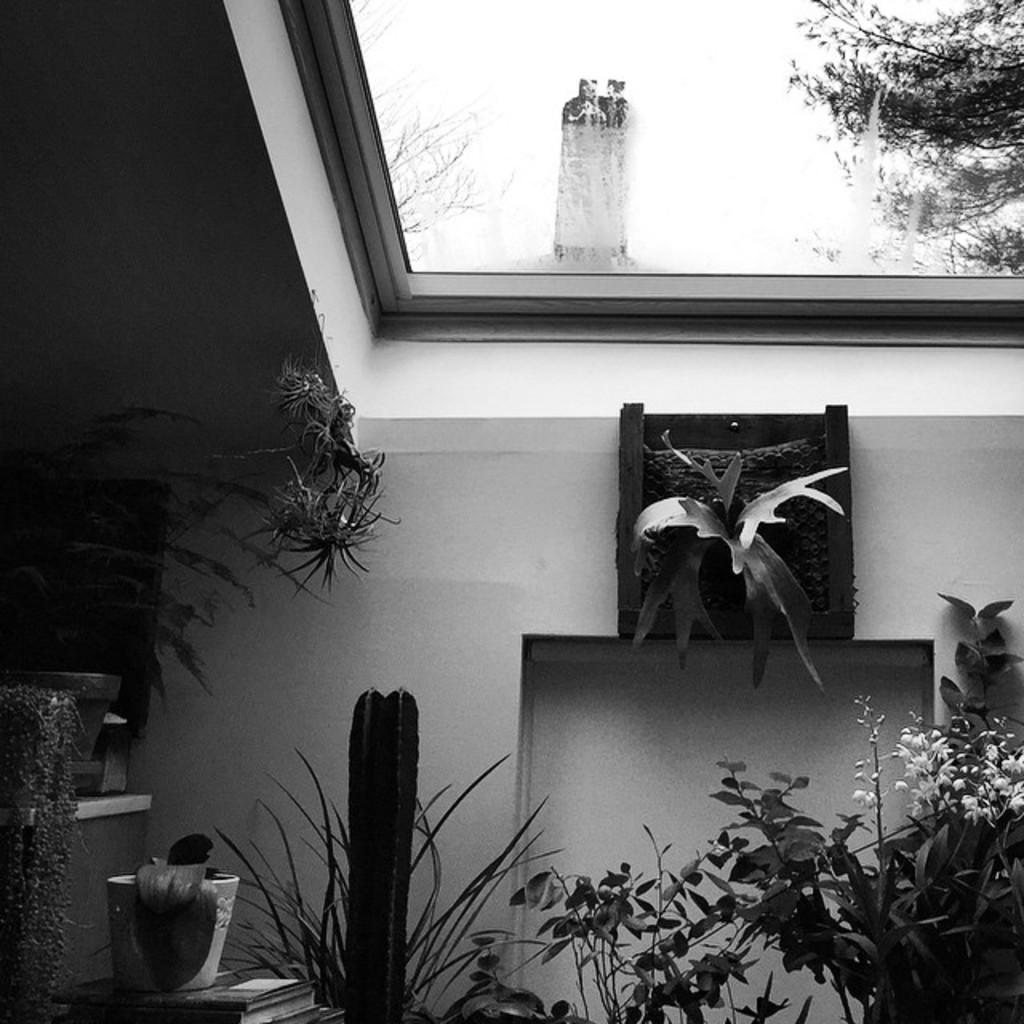What type of structure is in the picture? There is a house in the picture. What can be found inside the house? The house has house plants. What is above the house? There is an open space above the house. What can be seen from the open space? A part of a tree and the sky are visible from the open space. Where is the harbor located in the image? There is no harbor present in the image. How many kittens are playing with the whistle in the image? There are no kittens or whistles present in the image. 